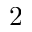<formula> <loc_0><loc_0><loc_500><loc_500>2</formula> 